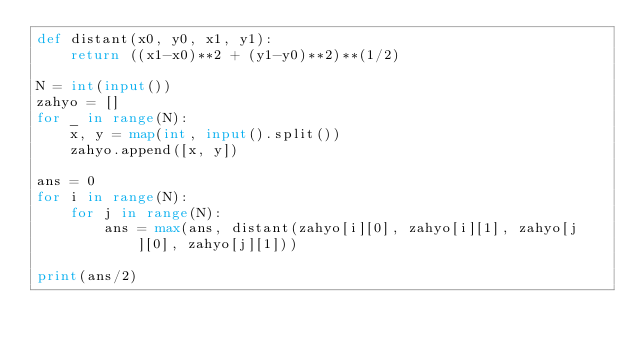<code> <loc_0><loc_0><loc_500><loc_500><_Python_>def distant(x0, y0, x1, y1):
    return ((x1-x0)**2 + (y1-y0)**2)**(1/2)

N = int(input())
zahyo = []
for _ in range(N):
    x, y = map(int, input().split())
    zahyo.append([x, y])

ans = 0
for i in range(N):
    for j in range(N):
        ans = max(ans, distant(zahyo[i][0], zahyo[i][1], zahyo[j][0], zahyo[j][1]))

print(ans/2)
</code> 